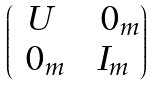<formula> <loc_0><loc_0><loc_500><loc_500>\begin{pmatrix} U \, & \ 0 _ { m } \\ \ 0 _ { m } \, & I _ { m } \end{pmatrix}</formula> 